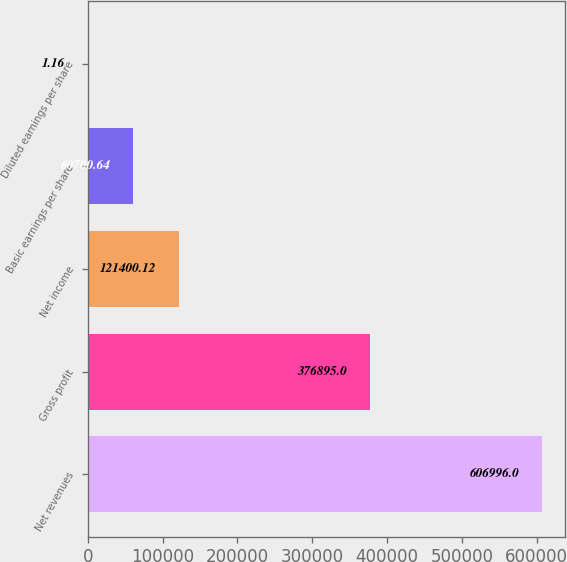<chart> <loc_0><loc_0><loc_500><loc_500><bar_chart><fcel>Net revenues<fcel>Gross profit<fcel>Net income<fcel>Basic earnings per share<fcel>Diluted earnings per share<nl><fcel>606996<fcel>376895<fcel>121400<fcel>60700.6<fcel>1.16<nl></chart> 